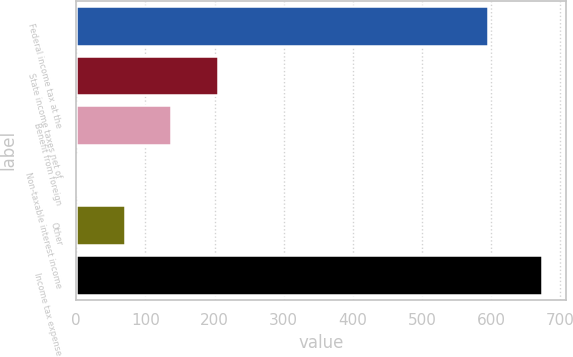Convert chart to OTSL. <chart><loc_0><loc_0><loc_500><loc_500><bar_chart><fcel>Federal income tax at the<fcel>State income taxes net of<fcel>Benefit from foreign<fcel>Non-taxable interest income<fcel>Other<fcel>Income tax expense<nl><fcel>595<fcel>204.3<fcel>137.2<fcel>3<fcel>70.1<fcel>674<nl></chart> 